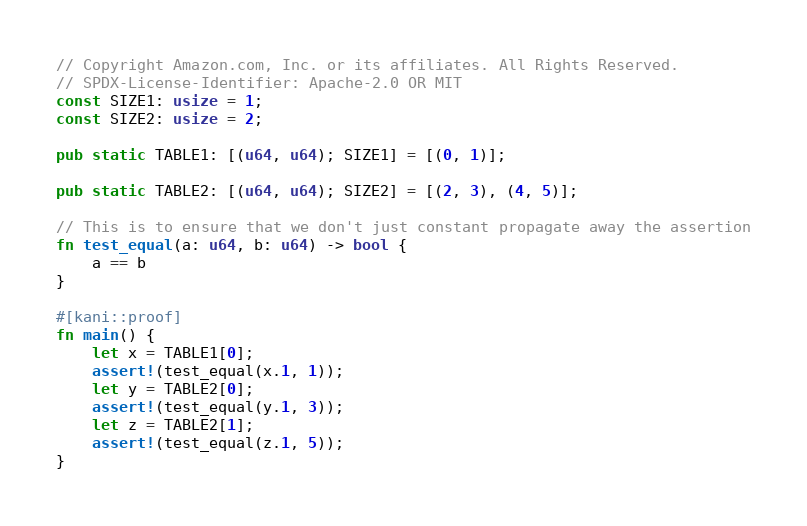<code> <loc_0><loc_0><loc_500><loc_500><_Rust_>// Copyright Amazon.com, Inc. or its affiliates. All Rights Reserved.
// SPDX-License-Identifier: Apache-2.0 OR MIT
const SIZE1: usize = 1;
const SIZE2: usize = 2;

pub static TABLE1: [(u64, u64); SIZE1] = [(0, 1)];

pub static TABLE2: [(u64, u64); SIZE2] = [(2, 3), (4, 5)];

// This is to ensure that we don't just constant propagate away the assertion
fn test_equal(a: u64, b: u64) -> bool {
    a == b
}

#[kani::proof]
fn main() {
    let x = TABLE1[0];
    assert!(test_equal(x.1, 1));
    let y = TABLE2[0];
    assert!(test_equal(y.1, 3));
    let z = TABLE2[1];
    assert!(test_equal(z.1, 5));
}
</code> 